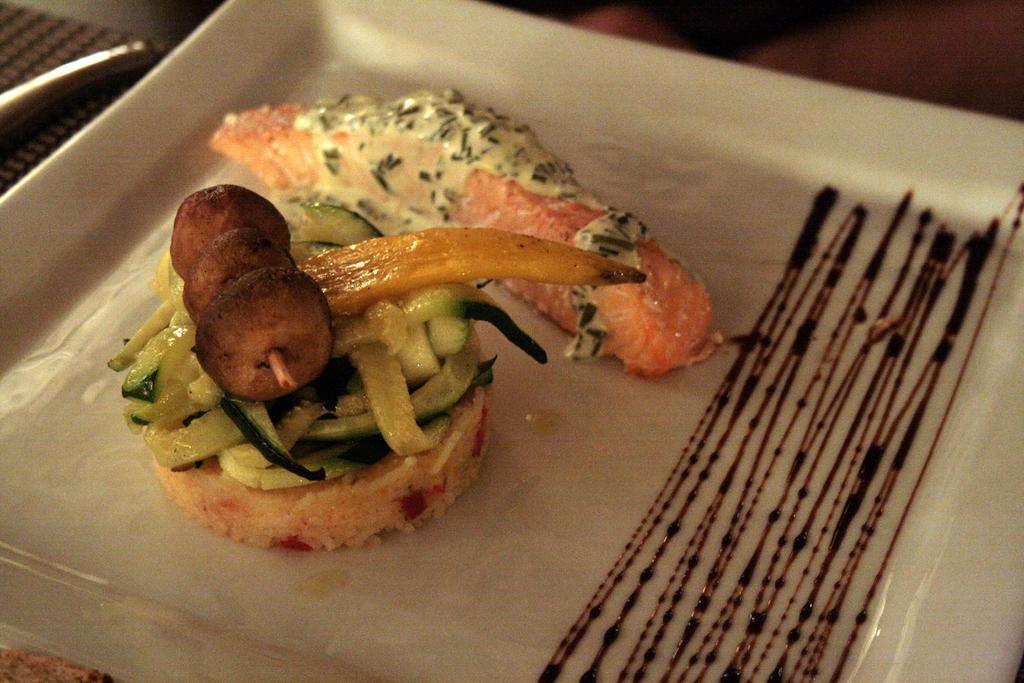Describe this image in one or two sentences. In this image there is a table with a napkin and a plate with a food item on it. 